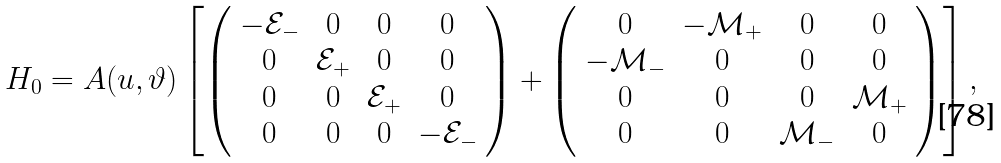<formula> <loc_0><loc_0><loc_500><loc_500>H _ { 0 } = A ( u , \vartheta ) \left [ \left ( \begin{array} { c c c c } - \mathcal { E } _ { - } & 0 & 0 & 0 \\ 0 & \mathcal { E } _ { + } & 0 & 0 \\ 0 & 0 & \mathcal { E } _ { + } & 0 \\ 0 & 0 & 0 & - \mathcal { E } _ { - } \end{array} \right ) + \left ( \begin{array} { c c c c } 0 & - \mathcal { M } _ { + } & 0 & 0 \\ - \mathcal { M } _ { - } & 0 & 0 & 0 \\ 0 & 0 & 0 & \mathcal { M } _ { + } \\ 0 & 0 & \mathcal { M } _ { - } & 0 \end{array} \right ) \right ] ,</formula> 